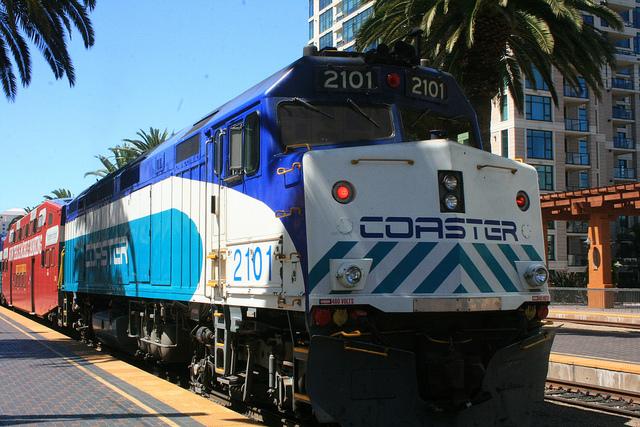Do you see any passengers?
Answer briefly. No. What is the name on the front of the train?
Short answer required. Coaster. What number does this train have on it?
Keep it brief. 2101. 